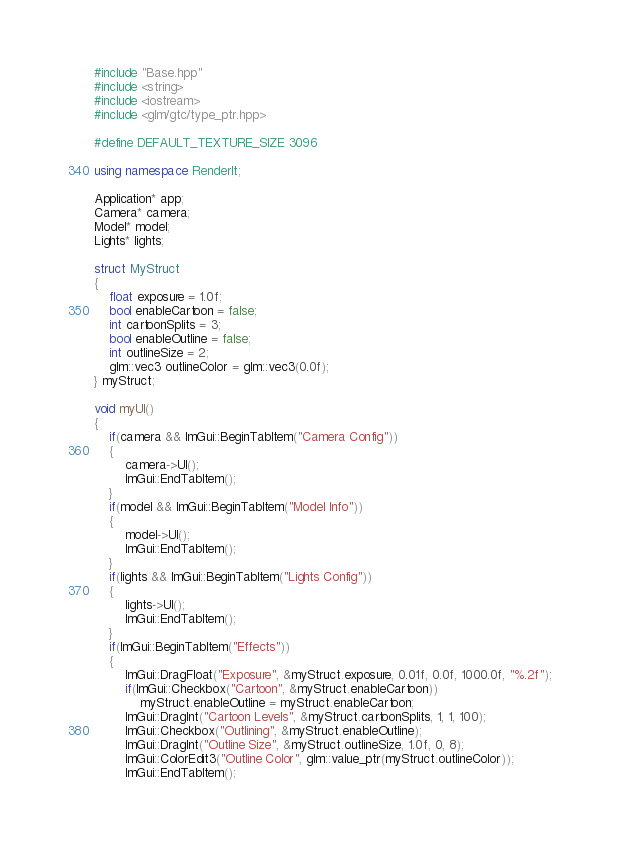Convert code to text. <code><loc_0><loc_0><loc_500><loc_500><_C++_>#include "Base.hpp"
#include <string>
#include <iostream>
#include <glm/gtc/type_ptr.hpp>

#define DEFAULT_TEXTURE_SIZE 3096

using namespace RenderIt;

Application* app;
Camera* camera;
Model* model;
Lights* lights;

struct MyStruct
{
    float exposure = 1.0f;
    bool enableCartoon = false;
    int cartoonSplits = 3;
    bool enableOutline = false;
    int outlineSize = 2;
    glm::vec3 outlineColor = glm::vec3(0.0f);
} myStruct;

void myUI()
{
    if(camera && ImGui::BeginTabItem("Camera Config"))
    {
        camera->UI();
        ImGui::EndTabItem();
    }
    if(model && ImGui::BeginTabItem("Model Info"))
    {
        model->UI();
        ImGui::EndTabItem();
    }
    if(lights && ImGui::BeginTabItem("Lights Config"))
    {
        lights->UI();
        ImGui::EndTabItem();
    }
    if(ImGui::BeginTabItem("Effects"))
    {
        ImGui::DragFloat("Exposure", &myStruct.exposure, 0.01f, 0.0f, 1000.0f, "%.2f");
        if(ImGui::Checkbox("Cartoon", &myStruct.enableCartoon))
            myStruct.enableOutline = myStruct.enableCartoon;
        ImGui::DragInt("Cartoon Levels", &myStruct.cartoonSplits, 1, 1, 100);
        ImGui::Checkbox("Outlining", &myStruct.enableOutline);
        ImGui::DragInt("Outline Size", &myStruct.outlineSize, 1.0f, 0, 8);
        ImGui::ColorEdit3("Outline Color", glm::value_ptr(myStruct.outlineColor));
        ImGui::EndTabItem();</code> 